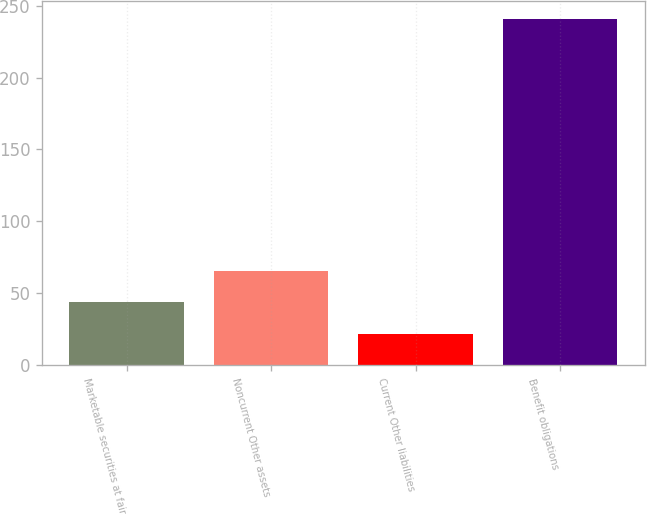Convert chart. <chart><loc_0><loc_0><loc_500><loc_500><bar_chart><fcel>Marketable securities at fair<fcel>Noncurrent Other assets<fcel>Current Other liabilities<fcel>Benefit obligations<nl><fcel>43.9<fcel>65.8<fcel>22<fcel>241<nl></chart> 